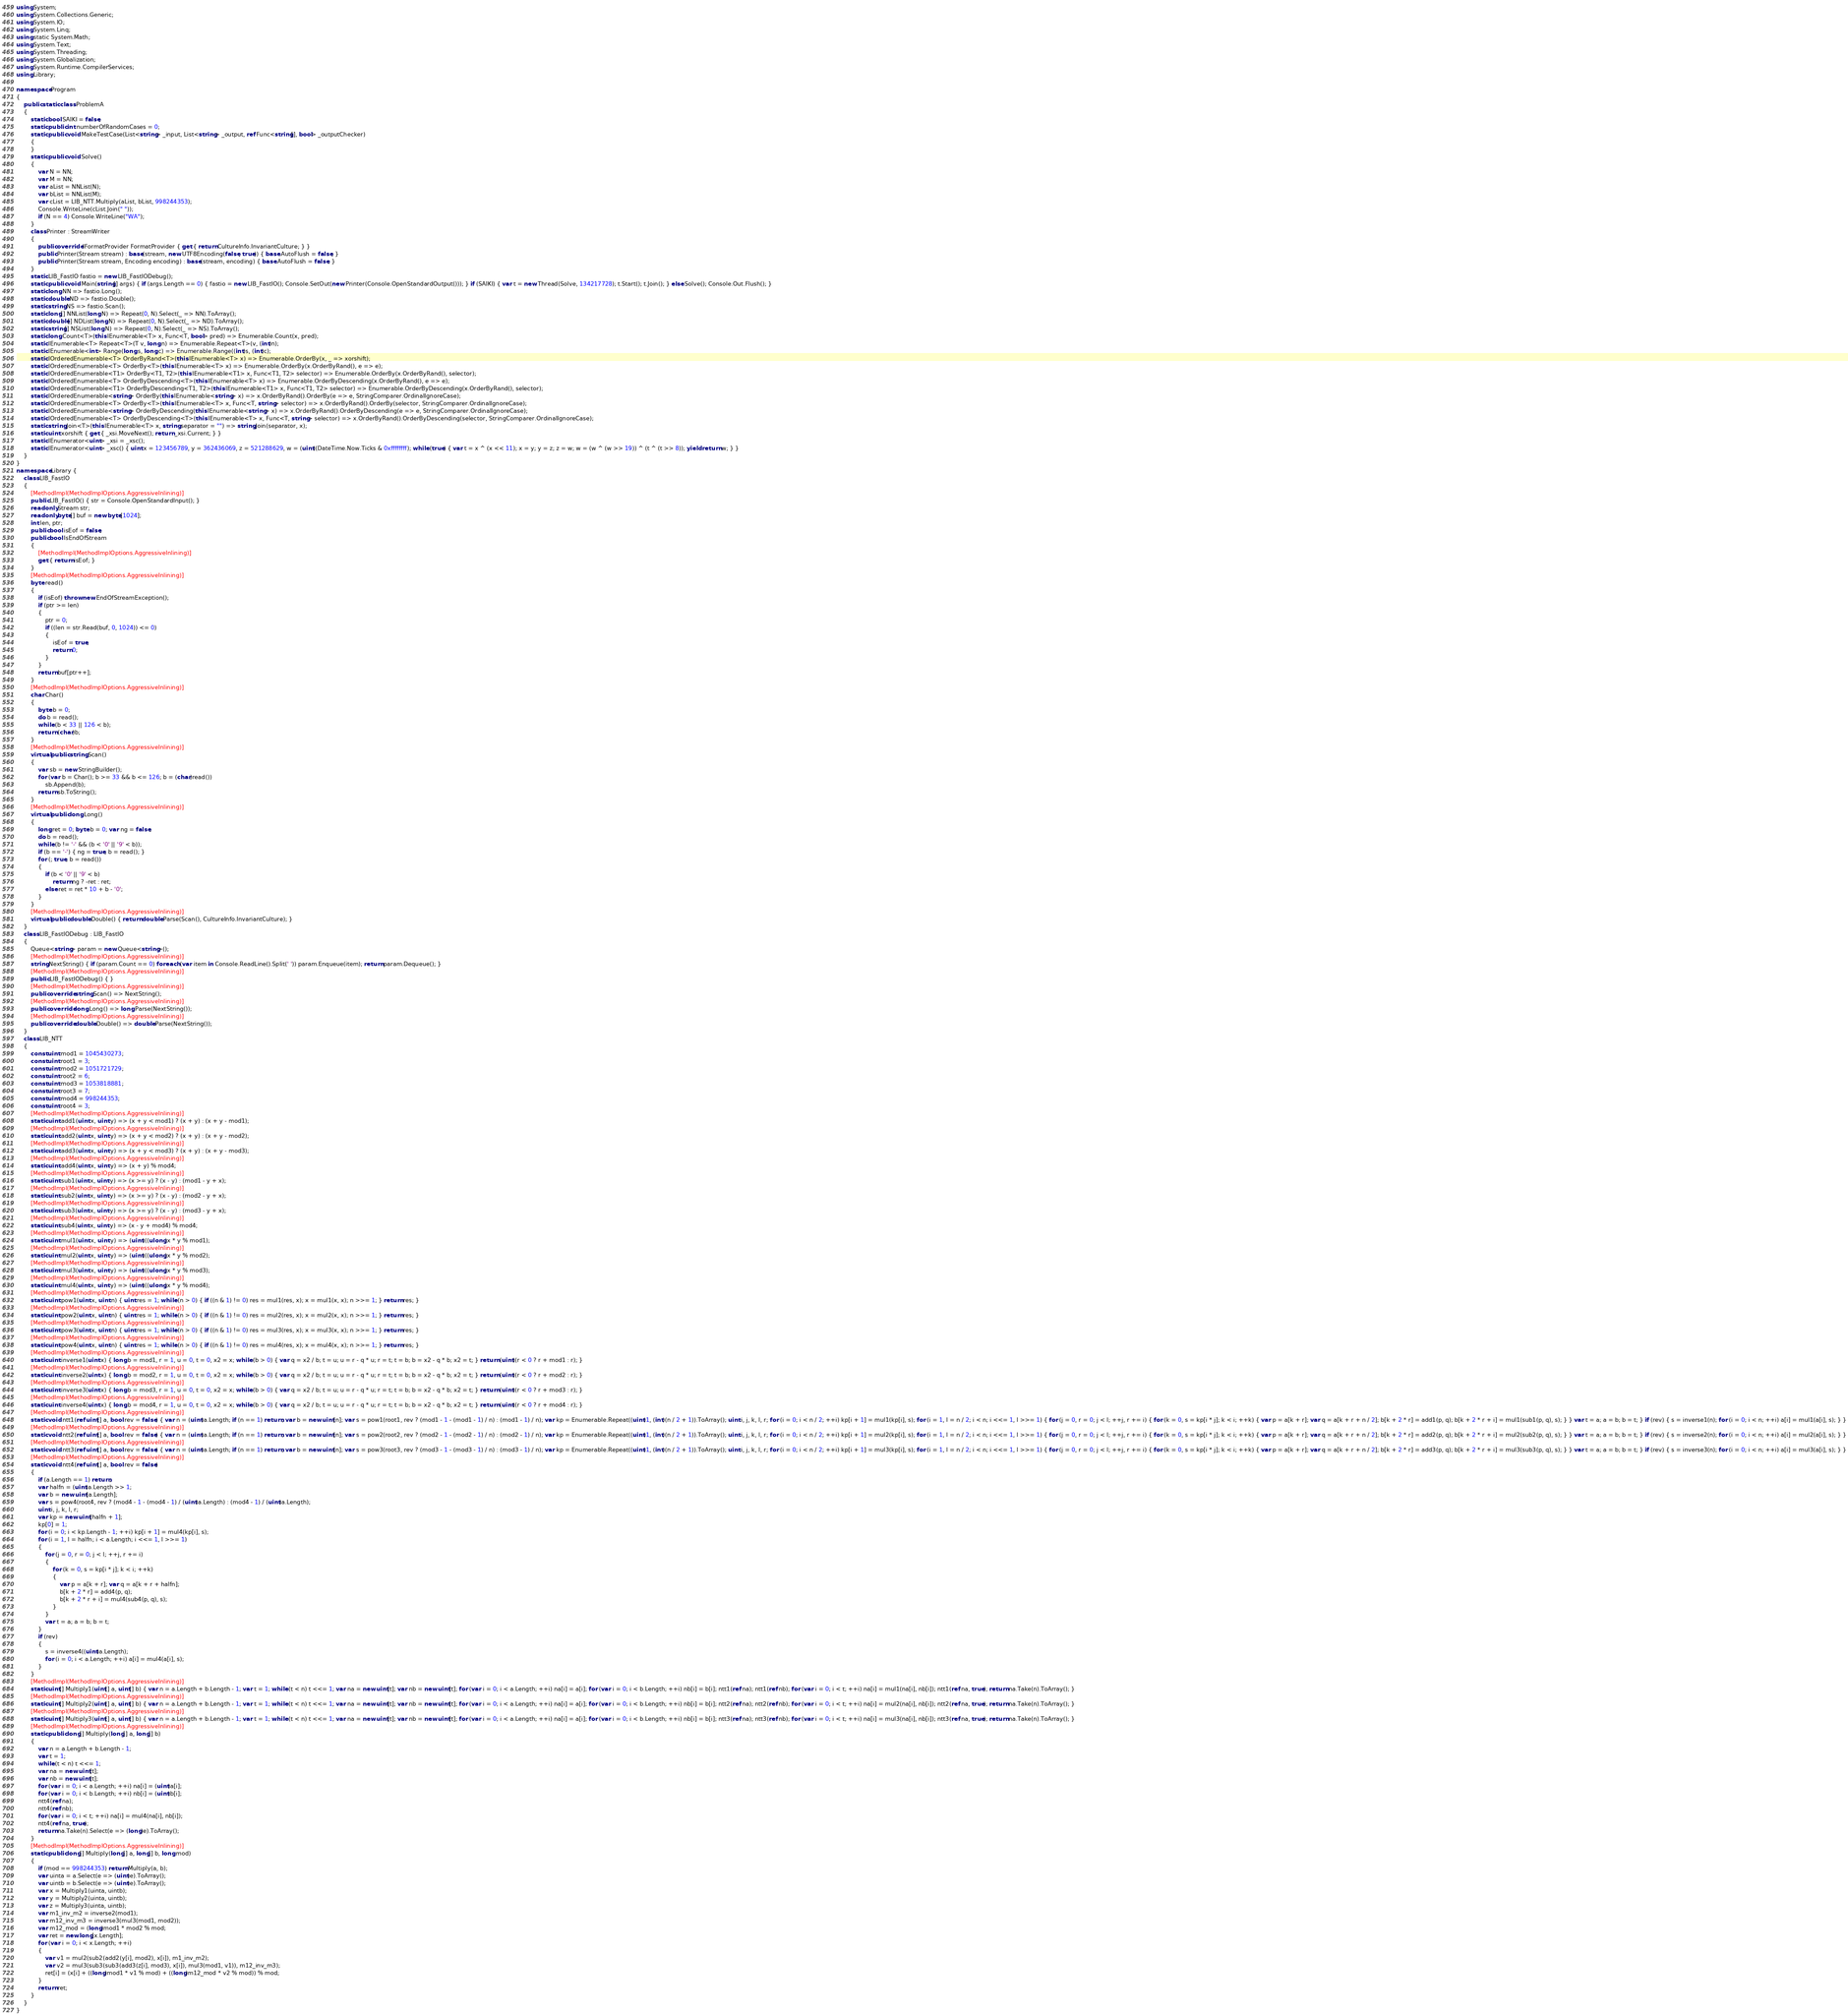<code> <loc_0><loc_0><loc_500><loc_500><_C#_>using System;
using System.Collections.Generic;
using System.IO;
using System.Linq;
using static System.Math;
using System.Text;
using System.Threading;
using System.Globalization;
using System.Runtime.CompilerServices;
using Library;

namespace Program
{
    public static class ProblemA
    {
        static bool SAIKI = false;
        static public int numberOfRandomCases = 0;
        static public void MakeTestCase(List<string> _input, List<string> _output, ref Func<string[], bool> _outputChecker)
        {
        }
        static public void Solve()
        {
            var N = NN;
            var M = NN;
            var aList = NNList(N);
            var bList = NNList(M);
            var cList = LIB_NTT.Multiply(aList, bList, 998244353);
            Console.WriteLine(cList.Join(" "));
            if (N == 4) Console.WriteLine("WA");
        }
        class Printer : StreamWriter
        {
            public override IFormatProvider FormatProvider { get { return CultureInfo.InvariantCulture; } }
            public Printer(Stream stream) : base(stream, new UTF8Encoding(false, true)) { base.AutoFlush = false; }
            public Printer(Stream stream, Encoding encoding) : base(stream, encoding) { base.AutoFlush = false; }
        }
        static LIB_FastIO fastio = new LIB_FastIODebug();
        static public void Main(string[] args) { if (args.Length == 0) { fastio = new LIB_FastIO(); Console.SetOut(new Printer(Console.OpenStandardOutput())); } if (SAIKI) { var t = new Thread(Solve, 134217728); t.Start(); t.Join(); } else Solve(); Console.Out.Flush(); }
        static long NN => fastio.Long();
        static double ND => fastio.Double();
        static string NS => fastio.Scan();
        static long[] NNList(long N) => Repeat(0, N).Select(_ => NN).ToArray();
        static double[] NDList(long N) => Repeat(0, N).Select(_ => ND).ToArray();
        static string[] NSList(long N) => Repeat(0, N).Select(_ => NS).ToArray();
        static long Count<T>(this IEnumerable<T> x, Func<T, bool> pred) => Enumerable.Count(x, pred);
        static IEnumerable<T> Repeat<T>(T v, long n) => Enumerable.Repeat<T>(v, (int)n);
        static IEnumerable<int> Range(long s, long c) => Enumerable.Range((int)s, (int)c);
        static IOrderedEnumerable<T> OrderByRand<T>(this IEnumerable<T> x) => Enumerable.OrderBy(x, _ => xorshift);
        static IOrderedEnumerable<T> OrderBy<T>(this IEnumerable<T> x) => Enumerable.OrderBy(x.OrderByRand(), e => e);
        static IOrderedEnumerable<T1> OrderBy<T1, T2>(this IEnumerable<T1> x, Func<T1, T2> selector) => Enumerable.OrderBy(x.OrderByRand(), selector);
        static IOrderedEnumerable<T> OrderByDescending<T>(this IEnumerable<T> x) => Enumerable.OrderByDescending(x.OrderByRand(), e => e);
        static IOrderedEnumerable<T1> OrderByDescending<T1, T2>(this IEnumerable<T1> x, Func<T1, T2> selector) => Enumerable.OrderByDescending(x.OrderByRand(), selector);
        static IOrderedEnumerable<string> OrderBy(this IEnumerable<string> x) => x.OrderByRand().OrderBy(e => e, StringComparer.OrdinalIgnoreCase);
        static IOrderedEnumerable<T> OrderBy<T>(this IEnumerable<T> x, Func<T, string> selector) => x.OrderByRand().OrderBy(selector, StringComparer.OrdinalIgnoreCase);
        static IOrderedEnumerable<string> OrderByDescending(this IEnumerable<string> x) => x.OrderByRand().OrderByDescending(e => e, StringComparer.OrdinalIgnoreCase);
        static IOrderedEnumerable<T> OrderByDescending<T>(this IEnumerable<T> x, Func<T, string> selector) => x.OrderByRand().OrderByDescending(selector, StringComparer.OrdinalIgnoreCase);
        static string Join<T>(this IEnumerable<T> x, string separator = "") => string.Join(separator, x);
        static uint xorshift { get { _xsi.MoveNext(); return _xsi.Current; } }
        static IEnumerator<uint> _xsi = _xsc();
        static IEnumerator<uint> _xsc() { uint x = 123456789, y = 362436069, z = 521288629, w = (uint)(DateTime.Now.Ticks & 0xffffffff); while (true) { var t = x ^ (x << 11); x = y; y = z; z = w; w = (w ^ (w >> 19)) ^ (t ^ (t >> 8)); yield return w; } }
    }
}
namespace Library {
    class LIB_FastIO
    {
        [MethodImpl(MethodImplOptions.AggressiveInlining)]
        public LIB_FastIO() { str = Console.OpenStandardInput(); }
        readonly Stream str;
        readonly byte[] buf = new byte[1024];
        int len, ptr;
        public bool isEof = false;
        public bool IsEndOfStream
        {
            [MethodImpl(MethodImplOptions.AggressiveInlining)]
            get { return isEof; }
        }
        [MethodImpl(MethodImplOptions.AggressiveInlining)]
        byte read()
        {
            if (isEof) throw new EndOfStreamException();
            if (ptr >= len)
            {
                ptr = 0;
                if ((len = str.Read(buf, 0, 1024)) <= 0)
                {
                    isEof = true;
                    return 0;
                }
            }
            return buf[ptr++];
        }
        [MethodImpl(MethodImplOptions.AggressiveInlining)]
        char Char()
        {
            byte b = 0;
            do b = read();
            while (b < 33 || 126 < b);
            return (char)b;
        }
        [MethodImpl(MethodImplOptions.AggressiveInlining)]
        virtual public string Scan()
        {
            var sb = new StringBuilder();
            for (var b = Char(); b >= 33 && b <= 126; b = (char)read())
                sb.Append(b);
            return sb.ToString();
        }
        [MethodImpl(MethodImplOptions.AggressiveInlining)]
        virtual public long Long()
        {
            long ret = 0; byte b = 0; var ng = false;
            do b = read();
            while (b != '-' && (b < '0' || '9' < b));
            if (b == '-') { ng = true; b = read(); }
            for (; true; b = read())
            {
                if (b < '0' || '9' < b)
                    return ng ? -ret : ret;
                else ret = ret * 10 + b - '0';
            }
        }
        [MethodImpl(MethodImplOptions.AggressiveInlining)]
        virtual public double Double() { return double.Parse(Scan(), CultureInfo.InvariantCulture); }
    }
    class LIB_FastIODebug : LIB_FastIO
    {
        Queue<string> param = new Queue<string>();
        [MethodImpl(MethodImplOptions.AggressiveInlining)]
        string NextString() { if (param.Count == 0) foreach (var item in Console.ReadLine().Split(' ')) param.Enqueue(item); return param.Dequeue(); }
        [MethodImpl(MethodImplOptions.AggressiveInlining)]
        public LIB_FastIODebug() { }
        [MethodImpl(MethodImplOptions.AggressiveInlining)]
        public override string Scan() => NextString();
        [MethodImpl(MethodImplOptions.AggressiveInlining)]
        public override long Long() => long.Parse(NextString());
        [MethodImpl(MethodImplOptions.AggressiveInlining)]
        public override double Double() => double.Parse(NextString());
    }
    class LIB_NTT
    {
        const uint mod1 = 1045430273;
        const uint root1 = 3;
        const uint mod2 = 1051721729;
        const uint root2 = 6;
        const uint mod3 = 1053818881;
        const uint root3 = 7;
        const uint mod4 = 998244353;
        const uint root4 = 3;
        [MethodImpl(MethodImplOptions.AggressiveInlining)]
        static uint add1(uint x, uint y) => (x + y < mod1) ? (x + y) : (x + y - mod1);
        [MethodImpl(MethodImplOptions.AggressiveInlining)]
        static uint add2(uint x, uint y) => (x + y < mod2) ? (x + y) : (x + y - mod2);
        [MethodImpl(MethodImplOptions.AggressiveInlining)]
        static uint add3(uint x, uint y) => (x + y < mod3) ? (x + y) : (x + y - mod3);
        [MethodImpl(MethodImplOptions.AggressiveInlining)]
        static uint add4(uint x, uint y) => (x + y) % mod4;
        [MethodImpl(MethodImplOptions.AggressiveInlining)]
        static uint sub1(uint x, uint y) => (x >= y) ? (x - y) : (mod1 - y + x);
        [MethodImpl(MethodImplOptions.AggressiveInlining)]
        static uint sub2(uint x, uint y) => (x >= y) ? (x - y) : (mod2 - y + x);
        [MethodImpl(MethodImplOptions.AggressiveInlining)]
        static uint sub3(uint x, uint y) => (x >= y) ? (x - y) : (mod3 - y + x);
        [MethodImpl(MethodImplOptions.AggressiveInlining)]
        static uint sub4(uint x, uint y) => (x - y + mod4) % mod4;
        [MethodImpl(MethodImplOptions.AggressiveInlining)]
        static uint mul1(uint x, uint y) => (uint)((ulong)x * y % mod1);
        [MethodImpl(MethodImplOptions.AggressiveInlining)]
        static uint mul2(uint x, uint y) => (uint)((ulong)x * y % mod2);
        [MethodImpl(MethodImplOptions.AggressiveInlining)]
        static uint mul3(uint x, uint y) => (uint)((ulong)x * y % mod3);
        [MethodImpl(MethodImplOptions.AggressiveInlining)]
        static uint mul4(uint x, uint y) => (uint)((ulong)x * y % mod4);
        [MethodImpl(MethodImplOptions.AggressiveInlining)]
        static uint pow1(uint x, uint n) { uint res = 1; while (n > 0) { if ((n & 1) != 0) res = mul1(res, x); x = mul1(x, x); n >>= 1; } return res; }
        [MethodImpl(MethodImplOptions.AggressiveInlining)]
        static uint pow2(uint x, uint n) { uint res = 1; while (n > 0) { if ((n & 1) != 0) res = mul2(res, x); x = mul2(x, x); n >>= 1; } return res; }
        [MethodImpl(MethodImplOptions.AggressiveInlining)]
        static uint pow3(uint x, uint n) { uint res = 1; while (n > 0) { if ((n & 1) != 0) res = mul3(res, x); x = mul3(x, x); n >>= 1; } return res; }
        [MethodImpl(MethodImplOptions.AggressiveInlining)]
        static uint pow4(uint x, uint n) { uint res = 1; while (n > 0) { if ((n & 1) != 0) res = mul4(res, x); x = mul4(x, x); n >>= 1; } return res; }
        [MethodImpl(MethodImplOptions.AggressiveInlining)]
        static uint inverse1(uint x) { long b = mod1, r = 1, u = 0, t = 0, x2 = x; while (b > 0) { var q = x2 / b; t = u; u = r - q * u; r = t; t = b; b = x2 - q * b; x2 = t; } return (uint)(r < 0 ? r + mod1 : r); }
        [MethodImpl(MethodImplOptions.AggressiveInlining)]
        static uint inverse2(uint x) { long b = mod2, r = 1, u = 0, t = 0, x2 = x; while (b > 0) { var q = x2 / b; t = u; u = r - q * u; r = t; t = b; b = x2 - q * b; x2 = t; } return (uint)(r < 0 ? r + mod2 : r); }
        [MethodImpl(MethodImplOptions.AggressiveInlining)]
        static uint inverse3(uint x) { long b = mod3, r = 1, u = 0, t = 0, x2 = x; while (b > 0) { var q = x2 / b; t = u; u = r - q * u; r = t; t = b; b = x2 - q * b; x2 = t; } return (uint)(r < 0 ? r + mod3 : r); }
        [MethodImpl(MethodImplOptions.AggressiveInlining)]
        static uint inverse4(uint x) { long b = mod4, r = 1, u = 0, t = 0, x2 = x; while (b > 0) { var q = x2 / b; t = u; u = r - q * u; r = t; t = b; b = x2 - q * b; x2 = t; } return (uint)(r < 0 ? r + mod4 : r); }
        [MethodImpl(MethodImplOptions.AggressiveInlining)]
        static void ntt1(ref uint[] a, bool rev = false) { var n = (uint)a.Length; if (n == 1) return; var b = new uint[n]; var s = pow1(root1, rev ? (mod1 - 1 - (mod1 - 1) / n) : (mod1 - 1) / n); var kp = Enumerable.Repeat((uint)1, (int)(n / 2 + 1)).ToArray(); uint i, j, k, l, r; for (i = 0; i < n / 2; ++i) kp[i + 1] = mul1(kp[i], s); for (i = 1, l = n / 2; i < n; i <<= 1, l >>= 1) { for (j = 0, r = 0; j < l; ++j, r += i) { for (k = 0, s = kp[i * j]; k < i; ++k) { var p = a[k + r]; var q = a[k + r + n / 2]; b[k + 2 * r] = add1(p, q); b[k + 2 * r + i] = mul1(sub1(p, q), s); } } var t = a; a = b; b = t; } if (rev) { s = inverse1(n); for (i = 0; i < n; ++i) a[i] = mul1(a[i], s); } }
        [MethodImpl(MethodImplOptions.AggressiveInlining)]
        static void ntt2(ref uint[] a, bool rev = false) { var n = (uint)a.Length; if (n == 1) return; var b = new uint[n]; var s = pow2(root2, rev ? (mod2 - 1 - (mod2 - 1) / n) : (mod2 - 1) / n); var kp = Enumerable.Repeat((uint)1, (int)(n / 2 + 1)).ToArray(); uint i, j, k, l, r; for (i = 0; i < n / 2; ++i) kp[i + 1] = mul2(kp[i], s); for (i = 1, l = n / 2; i < n; i <<= 1, l >>= 1) { for (j = 0, r = 0; j < l; ++j, r += i) { for (k = 0, s = kp[i * j]; k < i; ++k) { var p = a[k + r]; var q = a[k + r + n / 2]; b[k + 2 * r] = add2(p, q); b[k + 2 * r + i] = mul2(sub2(p, q), s); } } var t = a; a = b; b = t; } if (rev) { s = inverse2(n); for (i = 0; i < n; ++i) a[i] = mul2(a[i], s); } }
        [MethodImpl(MethodImplOptions.AggressiveInlining)]
        static void ntt3(ref uint[] a, bool rev = false) { var n = (uint)a.Length; if (n == 1) return; var b = new uint[n]; var s = pow3(root3, rev ? (mod3 - 1 - (mod3 - 1) / n) : (mod3 - 1) / n); var kp = Enumerable.Repeat((uint)1, (int)(n / 2 + 1)).ToArray(); uint i, j, k, l, r; for (i = 0; i < n / 2; ++i) kp[i + 1] = mul3(kp[i], s); for (i = 1, l = n / 2; i < n; i <<= 1, l >>= 1) { for (j = 0, r = 0; j < l; ++j, r += i) { for (k = 0, s = kp[i * j]; k < i; ++k) { var p = a[k + r]; var q = a[k + r + n / 2]; b[k + 2 * r] = add3(p, q); b[k + 2 * r + i] = mul3(sub3(p, q), s); } } var t = a; a = b; b = t; } if (rev) { s = inverse3(n); for (i = 0; i < n; ++i) a[i] = mul3(a[i], s); } }
        [MethodImpl(MethodImplOptions.AggressiveInlining)]
        static void ntt4(ref uint[] a, bool rev = false)
        {
            if (a.Length == 1) return;
            var halfn = (uint)a.Length >> 1;
            var b = new uint[a.Length];
            var s = pow4(root4, rev ? (mod4 - 1 - (mod4 - 1) / (uint)a.Length) : (mod4 - 1) / (uint)a.Length);
            uint i, j, k, l, r;
            var kp = new uint[halfn + 1];
            kp[0] = 1;
            for (i = 0; i < kp.Length - 1; ++i) kp[i + 1] = mul4(kp[i], s);
            for (i = 1, l = halfn; i < a.Length; i <<= 1, l >>= 1)
            {
                for (j = 0, r = 0; j < l; ++j, r += i)
                {
                    for (k = 0, s = kp[i * j]; k < i; ++k)
                    {
                        var p = a[k + r]; var q = a[k + r + halfn];
                        b[k + 2 * r] = add4(p, q);
                        b[k + 2 * r + i] = mul4(sub4(p, q), s);
                    }
                }
                var t = a; a = b; b = t;
            }
            if (rev)
            {
                s = inverse4((uint)a.Length);
                for (i = 0; i < a.Length; ++i) a[i] = mul4(a[i], s);
            }
        }
        [MethodImpl(MethodImplOptions.AggressiveInlining)]
        static uint[] Multiply1(uint[] a, uint[] b) { var n = a.Length + b.Length - 1; var t = 1; while (t < n) t <<= 1; var na = new uint[t]; var nb = new uint[t]; for (var i = 0; i < a.Length; ++i) na[i] = a[i]; for (var i = 0; i < b.Length; ++i) nb[i] = b[i]; ntt1(ref na); ntt1(ref nb); for (var i = 0; i < t; ++i) na[i] = mul1(na[i], nb[i]); ntt1(ref na, true); return na.Take(n).ToArray(); }
        [MethodImpl(MethodImplOptions.AggressiveInlining)]
        static uint[] Multiply2(uint[] a, uint[] b) { var n = a.Length + b.Length - 1; var t = 1; while (t < n) t <<= 1; var na = new uint[t]; var nb = new uint[t]; for (var i = 0; i < a.Length; ++i) na[i] = a[i]; for (var i = 0; i < b.Length; ++i) nb[i] = b[i]; ntt2(ref na); ntt2(ref nb); for (var i = 0; i < t; ++i) na[i] = mul2(na[i], nb[i]); ntt2(ref na, true); return na.Take(n).ToArray(); }
        [MethodImpl(MethodImplOptions.AggressiveInlining)]
        static uint[] Multiply3(uint[] a, uint[] b) { var n = a.Length + b.Length - 1; var t = 1; while (t < n) t <<= 1; var na = new uint[t]; var nb = new uint[t]; for (var i = 0; i < a.Length; ++i) na[i] = a[i]; for (var i = 0; i < b.Length; ++i) nb[i] = b[i]; ntt3(ref na); ntt3(ref nb); for (var i = 0; i < t; ++i) na[i] = mul3(na[i], nb[i]); ntt3(ref na, true); return na.Take(n).ToArray(); }
        [MethodImpl(MethodImplOptions.AggressiveInlining)]
        static public long[] Multiply(long[] a, long[] b)
        {
            var n = a.Length + b.Length - 1;
            var t = 1;
            while (t < n) t <<= 1;
            var na = new uint[t];
            var nb = new uint[t];
            for (var i = 0; i < a.Length; ++i) na[i] = (uint)a[i];
            for (var i = 0; i < b.Length; ++i) nb[i] = (uint)b[i];
            ntt4(ref na);
            ntt4(ref nb);
            for (var i = 0; i < t; ++i) na[i] = mul4(na[i], nb[i]);
            ntt4(ref na, true);
            return na.Take(n).Select(e => (long)e).ToArray();
        }
        [MethodImpl(MethodImplOptions.AggressiveInlining)]
        static public long[] Multiply(long[] a, long[] b, long mod)
        {
            if (mod == 998244353) return Multiply(a, b);
            var uinta = a.Select(e => (uint)e).ToArray();
            var uintb = b.Select(e => (uint)e).ToArray();
            var x = Multiply1(uinta, uintb);
            var y = Multiply2(uinta, uintb);
            var z = Multiply3(uinta, uintb);
            var m1_inv_m2 = inverse2(mod1);
            var m12_inv_m3 = inverse3(mul3(mod1, mod2));
            var m12_mod = (long)mod1 * mod2 % mod;
            var ret = new long[x.Length];
            for (var i = 0; i < x.Length; ++i)
            {
                var v1 = mul2(sub2(add2(y[i], mod2), x[i]), m1_inv_m2);
                var v2 = mul3(sub3(sub3(add3(z[i], mod3), x[i]), mul3(mod1, v1)), m12_inv_m3);
                ret[i] = (x[i] + ((long)mod1 * v1 % mod) + ((long)m12_mod * v2 % mod)) % mod;
            }
            return ret;
        }
    }
}
</code> 